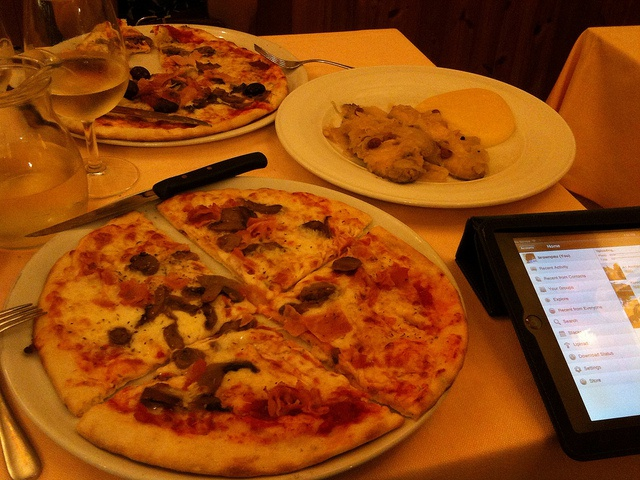Describe the objects in this image and their specific colors. I can see pizza in black, maroon, and red tones, dining table in black, red, and maroon tones, pizza in black, maroon, brown, and red tones, wine glass in black, brown, maroon, and orange tones, and dining table in black, orange, maroon, and red tones in this image. 